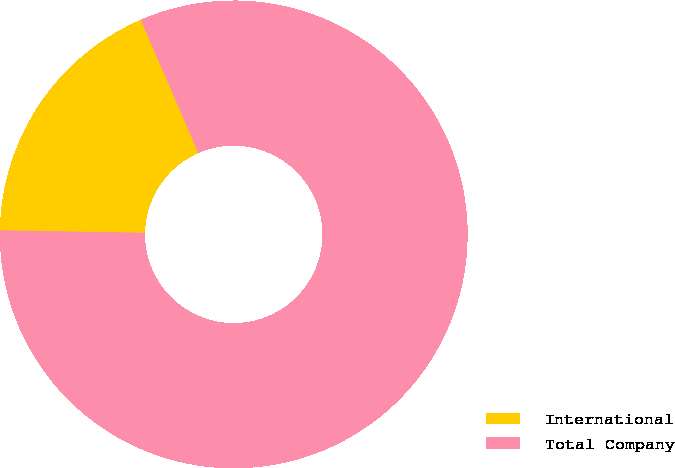<chart> <loc_0><loc_0><loc_500><loc_500><pie_chart><fcel>International<fcel>Total Company<nl><fcel>18.22%<fcel>81.78%<nl></chart> 